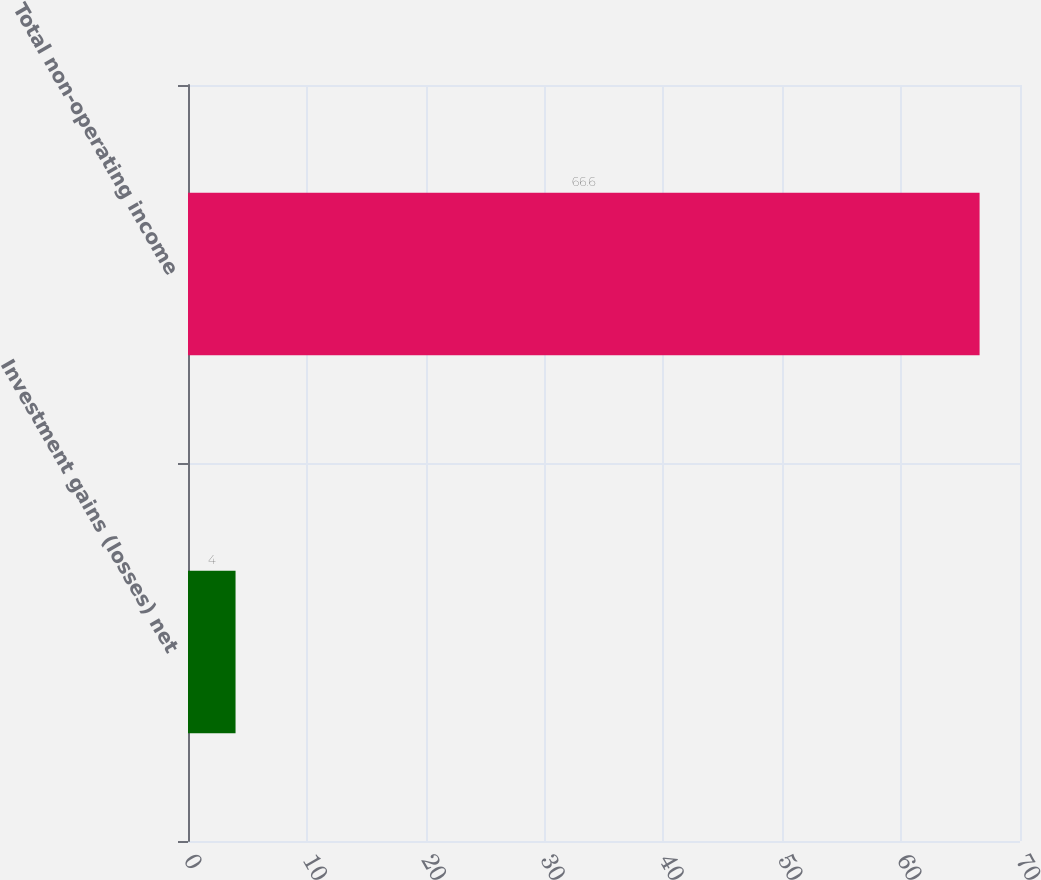Convert chart to OTSL. <chart><loc_0><loc_0><loc_500><loc_500><bar_chart><fcel>Investment gains (losses) net<fcel>Total non-operating income<nl><fcel>4<fcel>66.6<nl></chart> 